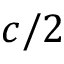Convert formula to latex. <formula><loc_0><loc_0><loc_500><loc_500>c / 2</formula> 